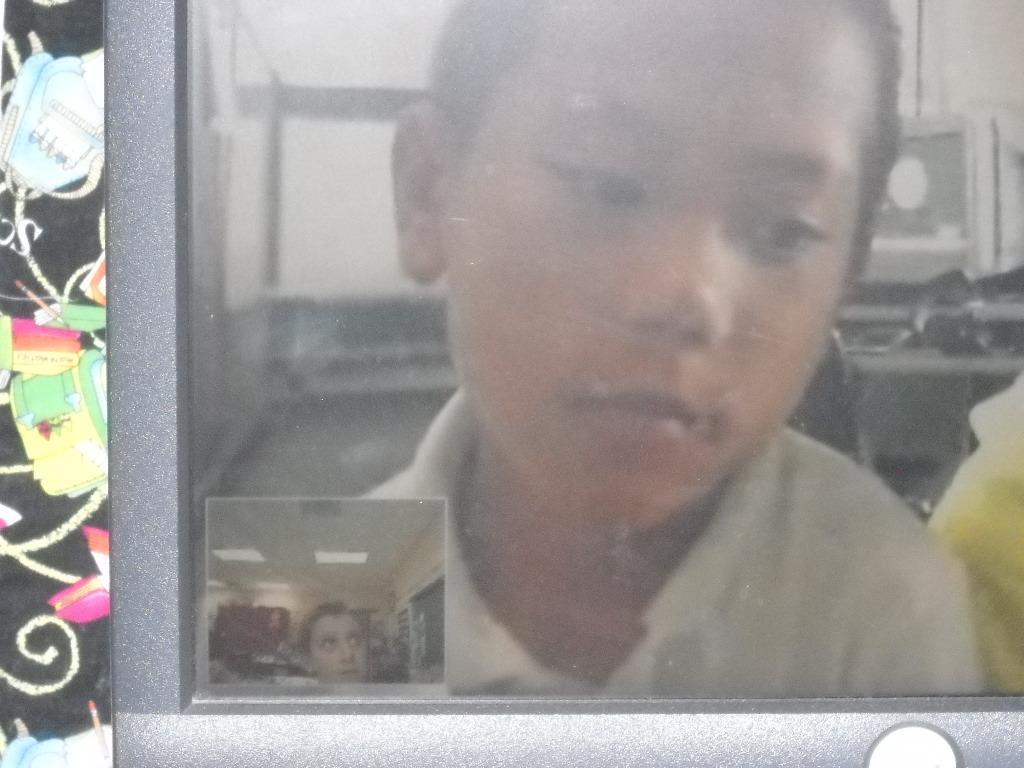Could you give a brief overview of what you see in this image? In this image we can see a child on a monitor screen. 